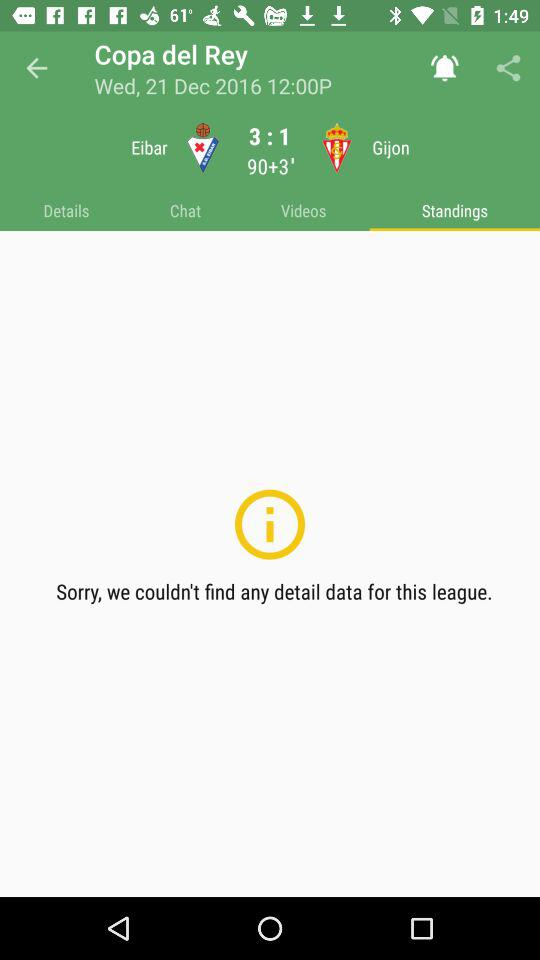What is the average score of Valencia and Leganes? The average score is 3-1. 